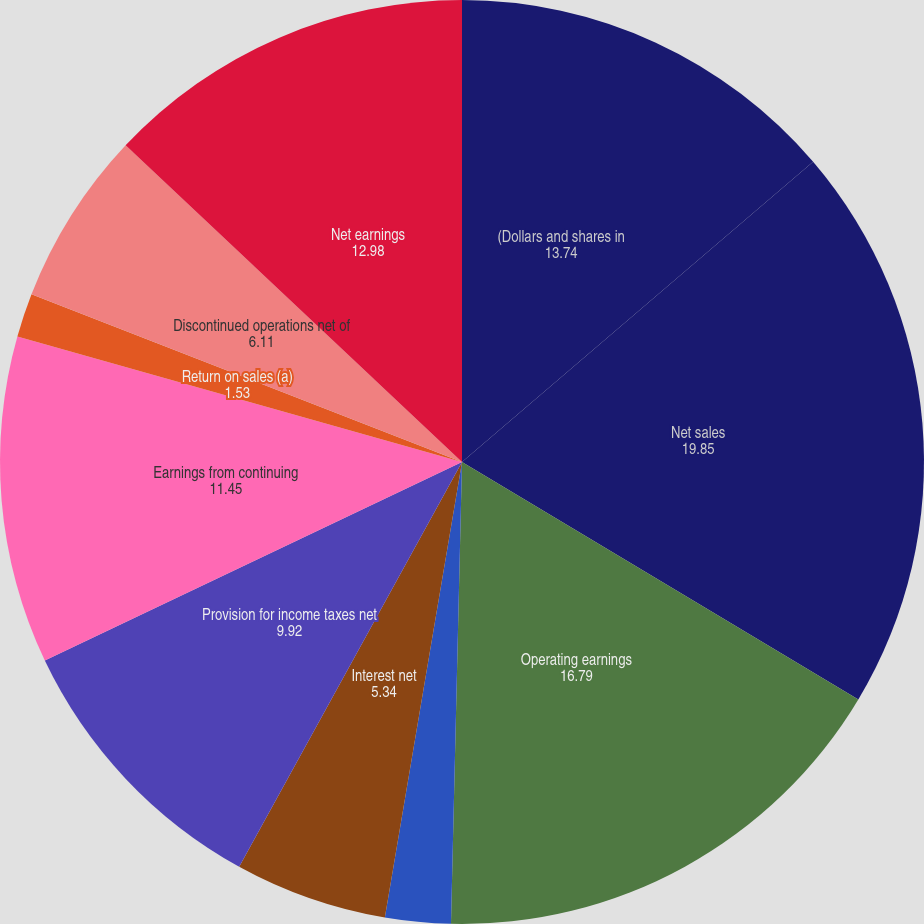Convert chart to OTSL. <chart><loc_0><loc_0><loc_500><loc_500><pie_chart><fcel>(Dollars and shares in<fcel>Net sales<fcel>Operating earnings<fcel>Operating margin<fcel>Interest net<fcel>Provision for income taxes net<fcel>Earnings from continuing<fcel>Return on sales (a)<fcel>Discontinued operations net of<fcel>Net earnings<nl><fcel>13.74%<fcel>19.85%<fcel>16.79%<fcel>2.29%<fcel>5.34%<fcel>9.92%<fcel>11.45%<fcel>1.53%<fcel>6.11%<fcel>12.98%<nl></chart> 